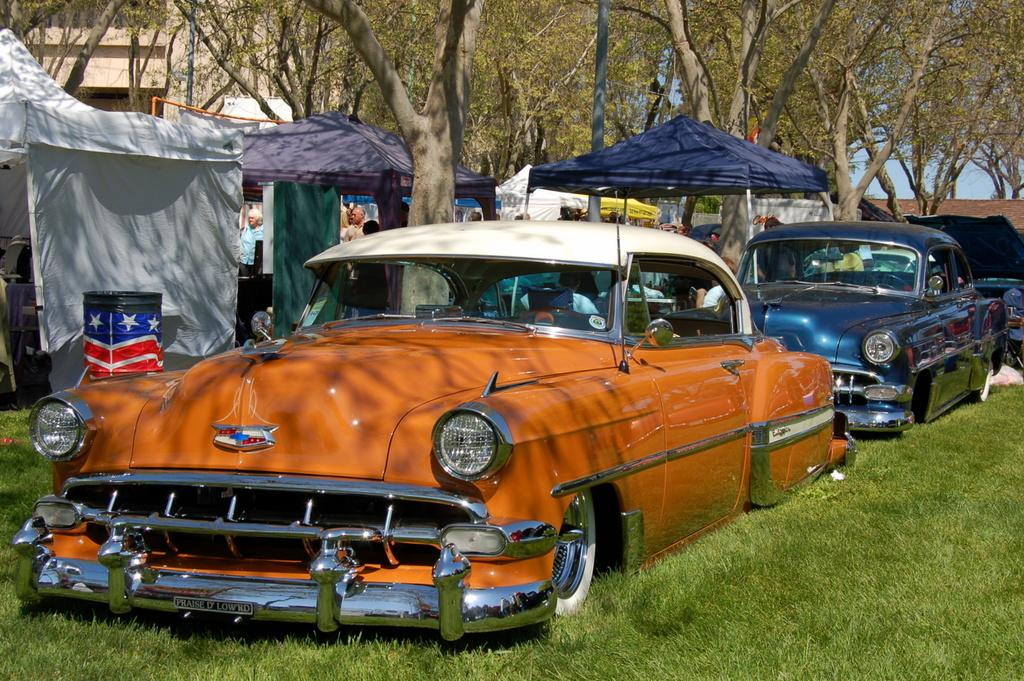What type of vegetation is present in the image? There is grass in the image. What types of man-made structures can be seen in the image? There are vehicles, tents, a building, and an object in the image. What natural elements are present in the image? There are trees in the image. What is the object in the image? The object in the image is not specified, but it is mentioned as being present. Can you describe the people in the image? There are people standing in the background of the image. What type of comfort can be seen in the image? There is no specific comfort item mentioned in the image, so it cannot be determined from the image. 